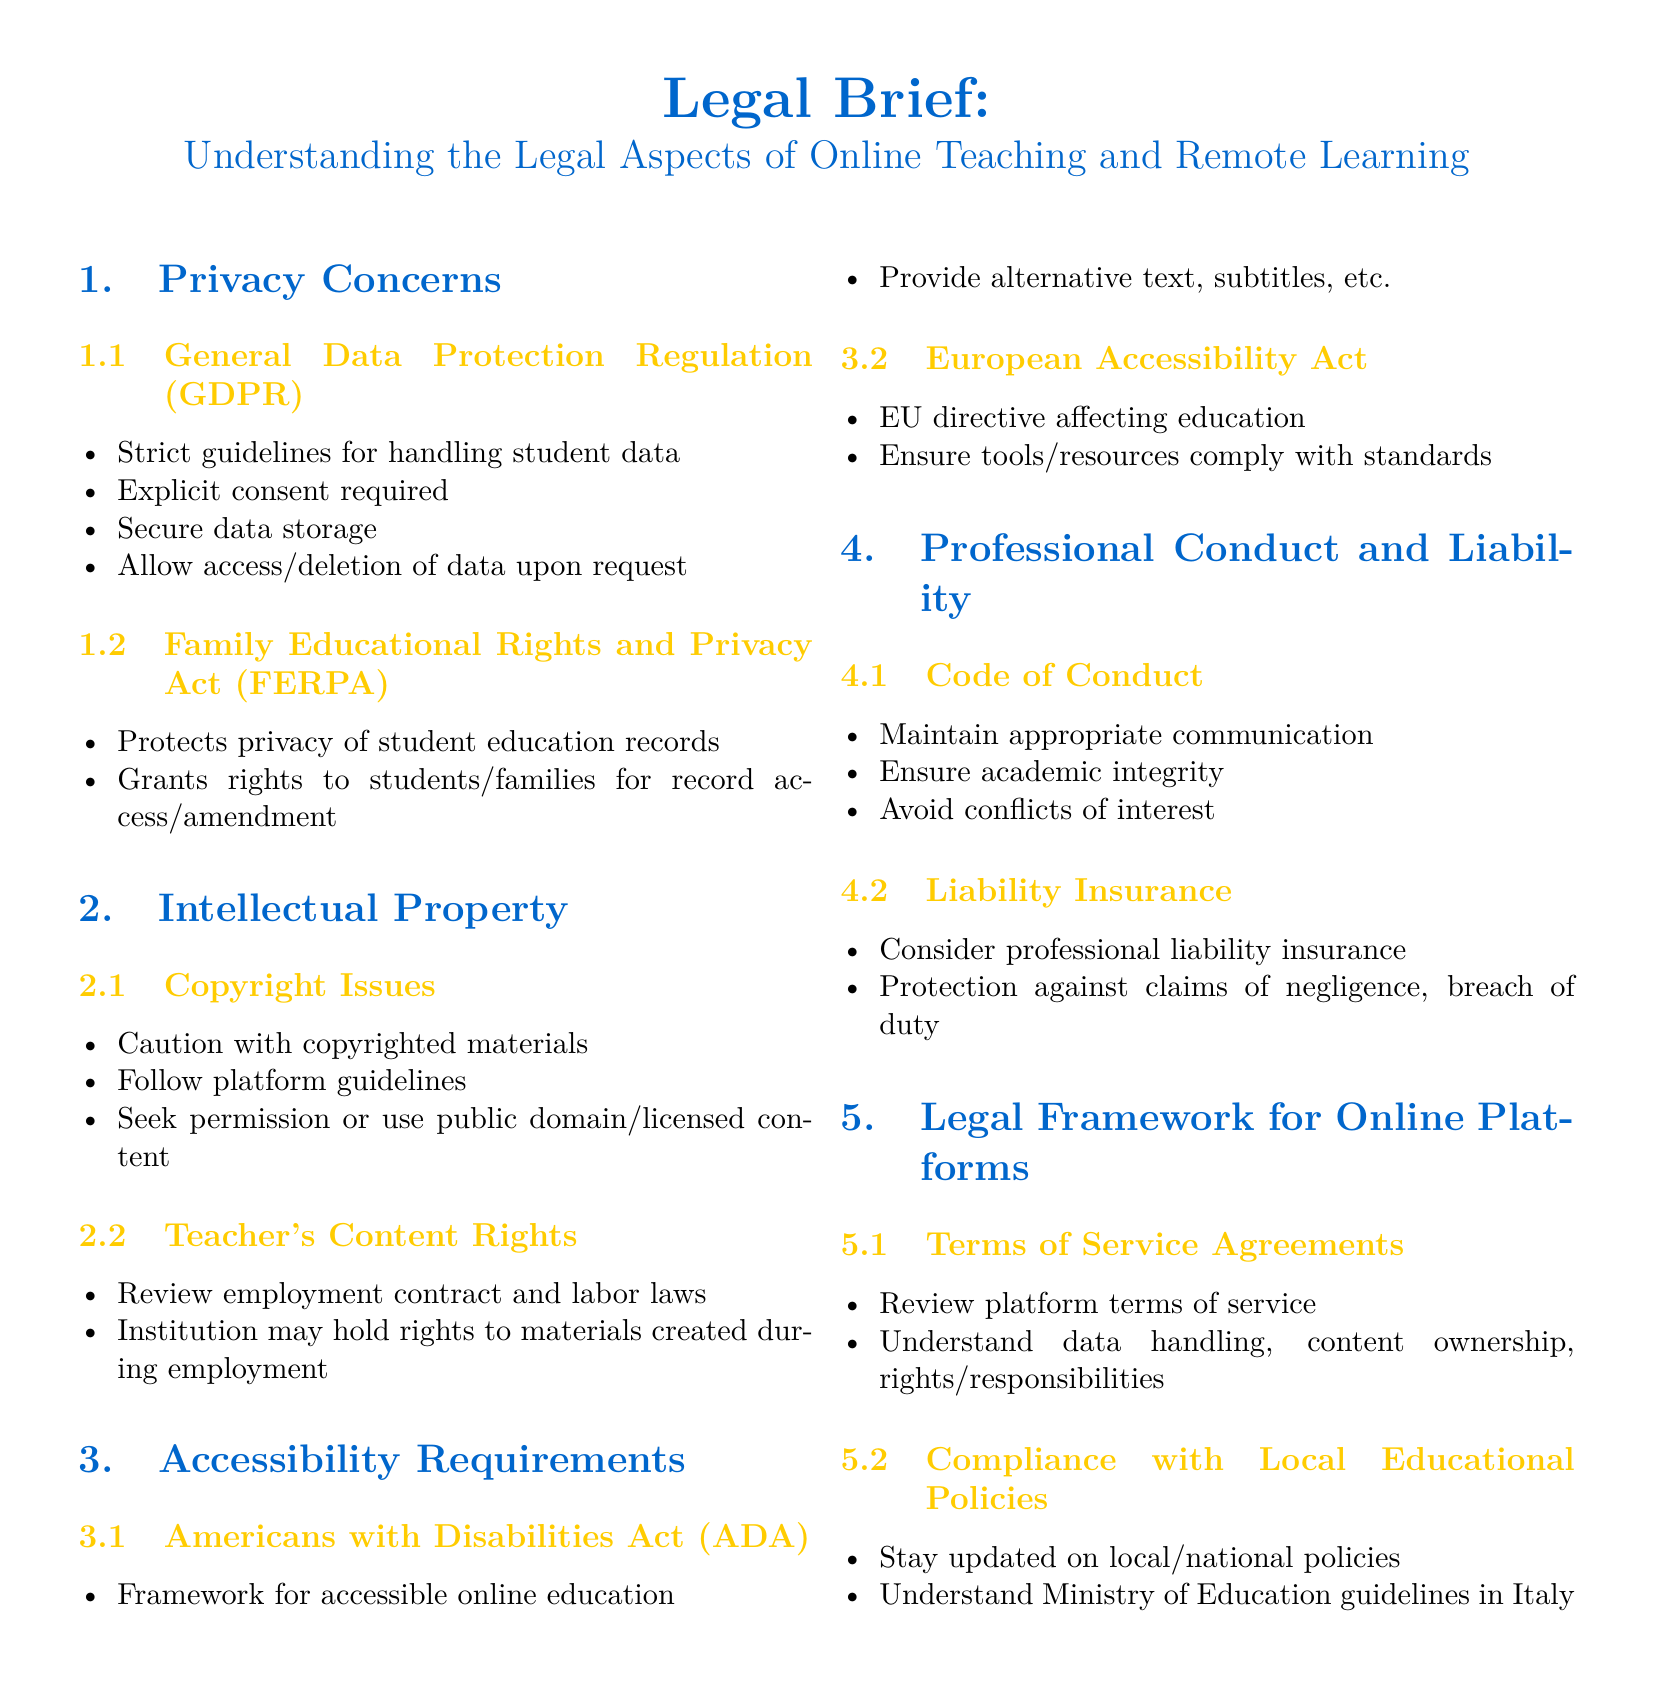What is the first privacy regulation mentioned? The document specifically mentions the General Data Protection Regulation (GDPR) as the first privacy regulation.
Answer: GDPR What does FERPA stand for? FERPA is an acronym for the Family Educational Rights and Privacy Act.
Answer: Family Educational Rights and Privacy Act What type of rights does the ADA establish? The Americans with Disabilities Act (ADA) establishes a framework for accessible online education.
Answer: Accessibility What is recommended when using copyrighted materials? The document advises caution with copyrighted materials and suggests following platform guidelines.
Answer: Caution What may affect an educator’s material rights? An educator's material rights may be impacted by reviewing their employment contract and labor laws.
Answer: Employment contract What does the document suggest regarding liability insurance? The document suggests considering professional liability insurance for protection against claims.
Answer: Professional liability insurance What do educators need to review for online platforms? Educators need to review the terms of service agreements for online platforms.
Answer: Terms of service agreements What must educators comply with in Italy? Educators must comply with Ministry of Education guidelines in Italy.
Answer: Ministry of Education guidelines 